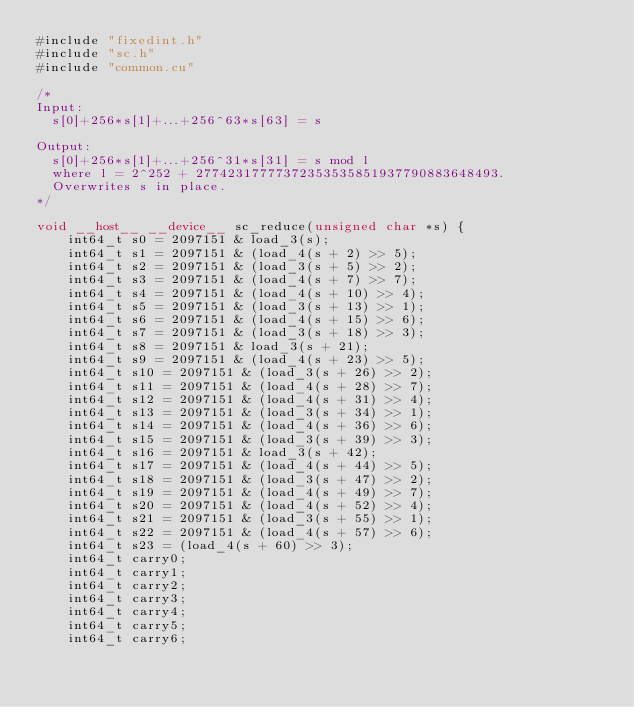Convert code to text. <code><loc_0><loc_0><loc_500><loc_500><_Cuda_>#include "fixedint.h"
#include "sc.h"
#include "common.cu"

/*
Input:
  s[0]+256*s[1]+...+256^63*s[63] = s

Output:
  s[0]+256*s[1]+...+256^31*s[31] = s mod l
  where l = 2^252 + 27742317777372353535851937790883648493.
  Overwrites s in place.
*/

void __host__ __device__ sc_reduce(unsigned char *s) {
    int64_t s0 = 2097151 & load_3(s);
    int64_t s1 = 2097151 & (load_4(s + 2) >> 5);
    int64_t s2 = 2097151 & (load_3(s + 5) >> 2);
    int64_t s3 = 2097151 & (load_4(s + 7) >> 7);
    int64_t s4 = 2097151 & (load_4(s + 10) >> 4);
    int64_t s5 = 2097151 & (load_3(s + 13) >> 1);
    int64_t s6 = 2097151 & (load_4(s + 15) >> 6);
    int64_t s7 = 2097151 & (load_3(s + 18) >> 3);
    int64_t s8 = 2097151 & load_3(s + 21);
    int64_t s9 = 2097151 & (load_4(s + 23) >> 5);
    int64_t s10 = 2097151 & (load_3(s + 26) >> 2);
    int64_t s11 = 2097151 & (load_4(s + 28) >> 7);
    int64_t s12 = 2097151 & (load_4(s + 31) >> 4);
    int64_t s13 = 2097151 & (load_3(s + 34) >> 1);
    int64_t s14 = 2097151 & (load_4(s + 36) >> 6);
    int64_t s15 = 2097151 & (load_3(s + 39) >> 3);
    int64_t s16 = 2097151 & load_3(s + 42);
    int64_t s17 = 2097151 & (load_4(s + 44) >> 5);
    int64_t s18 = 2097151 & (load_3(s + 47) >> 2);
    int64_t s19 = 2097151 & (load_4(s + 49) >> 7);
    int64_t s20 = 2097151 & (load_4(s + 52) >> 4);
    int64_t s21 = 2097151 & (load_3(s + 55) >> 1);
    int64_t s22 = 2097151 & (load_4(s + 57) >> 6);
    int64_t s23 = (load_4(s + 60) >> 3);
    int64_t carry0;
    int64_t carry1;
    int64_t carry2;
    int64_t carry3;
    int64_t carry4;
    int64_t carry5;
    int64_t carry6;</code> 